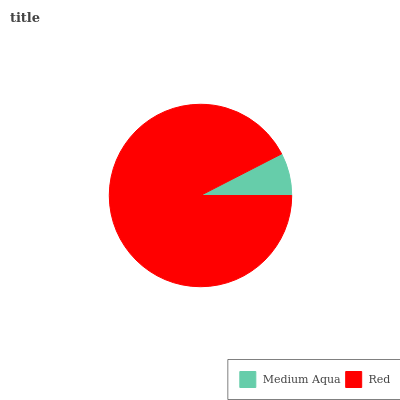Is Medium Aqua the minimum?
Answer yes or no. Yes. Is Red the maximum?
Answer yes or no. Yes. Is Red the minimum?
Answer yes or no. No. Is Red greater than Medium Aqua?
Answer yes or no. Yes. Is Medium Aqua less than Red?
Answer yes or no. Yes. Is Medium Aqua greater than Red?
Answer yes or no. No. Is Red less than Medium Aqua?
Answer yes or no. No. Is Red the high median?
Answer yes or no. Yes. Is Medium Aqua the low median?
Answer yes or no. Yes. Is Medium Aqua the high median?
Answer yes or no. No. Is Red the low median?
Answer yes or no. No. 